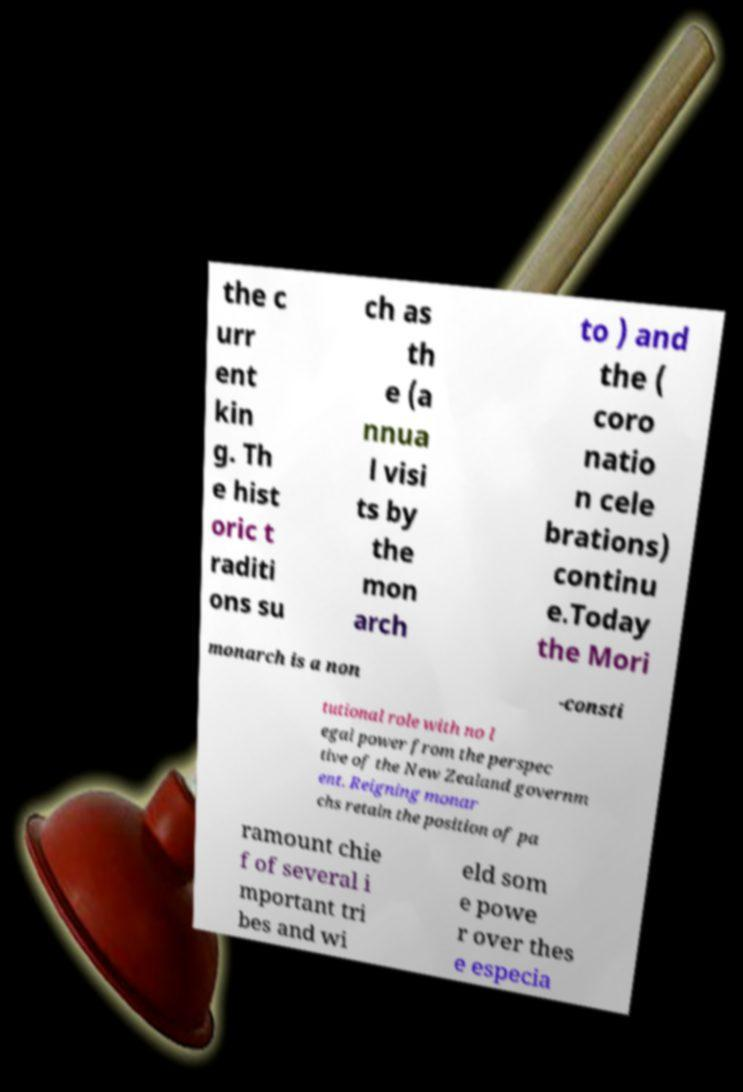What messages or text are displayed in this image? I need them in a readable, typed format. the c urr ent kin g. Th e hist oric t raditi ons su ch as th e (a nnua l visi ts by the mon arch to ) and the ( coro natio n cele brations) continu e.Today the Mori monarch is a non -consti tutional role with no l egal power from the perspec tive of the New Zealand governm ent. Reigning monar chs retain the position of pa ramount chie f of several i mportant tri bes and wi eld som e powe r over thes e especia 